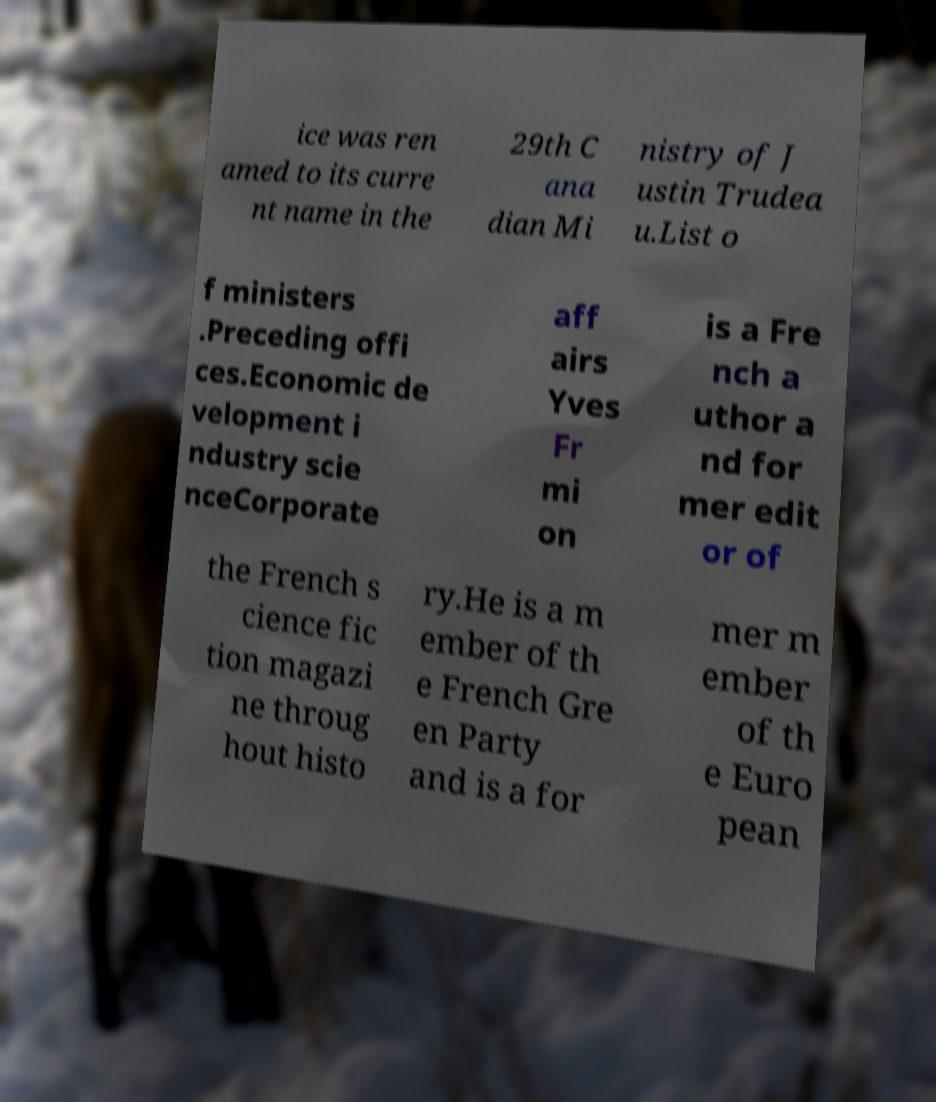Could you extract and type out the text from this image? ice was ren amed to its curre nt name in the 29th C ana dian Mi nistry of J ustin Trudea u.List o f ministers .Preceding offi ces.Economic de velopment i ndustry scie nceCorporate aff airs Yves Fr mi on is a Fre nch a uthor a nd for mer edit or of the French s cience fic tion magazi ne throug hout histo ry.He is a m ember of th e French Gre en Party and is a for mer m ember of th e Euro pean 